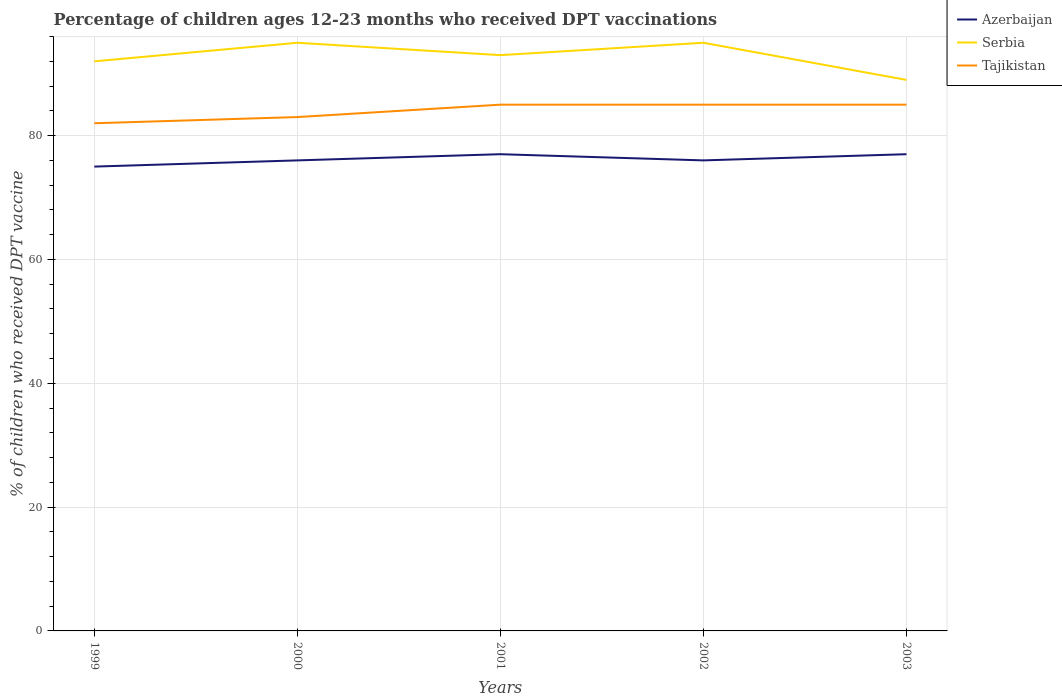How many different coloured lines are there?
Your answer should be very brief. 3. In which year was the percentage of children who received DPT vaccination in Serbia maximum?
Offer a very short reply. 2003. Is the percentage of children who received DPT vaccination in Azerbaijan strictly greater than the percentage of children who received DPT vaccination in Tajikistan over the years?
Your response must be concise. Yes. How many lines are there?
Make the answer very short. 3. How many years are there in the graph?
Make the answer very short. 5. What is the difference between two consecutive major ticks on the Y-axis?
Provide a short and direct response. 20. Are the values on the major ticks of Y-axis written in scientific E-notation?
Give a very brief answer. No. Does the graph contain any zero values?
Your response must be concise. No. What is the title of the graph?
Your response must be concise. Percentage of children ages 12-23 months who received DPT vaccinations. Does "Brunei Darussalam" appear as one of the legend labels in the graph?
Provide a succinct answer. No. What is the label or title of the X-axis?
Offer a very short reply. Years. What is the label or title of the Y-axis?
Offer a terse response. % of children who received DPT vaccine. What is the % of children who received DPT vaccine of Serbia in 1999?
Your answer should be very brief. 92. What is the % of children who received DPT vaccine in Tajikistan in 1999?
Offer a terse response. 82. What is the % of children who received DPT vaccine in Serbia in 2000?
Provide a succinct answer. 95. What is the % of children who received DPT vaccine in Serbia in 2001?
Your answer should be compact. 93. What is the % of children who received DPT vaccine in Tajikistan in 2001?
Give a very brief answer. 85. What is the % of children who received DPT vaccine in Azerbaijan in 2002?
Ensure brevity in your answer.  76. What is the % of children who received DPT vaccine in Azerbaijan in 2003?
Offer a very short reply. 77. What is the % of children who received DPT vaccine in Serbia in 2003?
Keep it short and to the point. 89. Across all years, what is the maximum % of children who received DPT vaccine in Azerbaijan?
Provide a succinct answer. 77. Across all years, what is the maximum % of children who received DPT vaccine of Serbia?
Your response must be concise. 95. Across all years, what is the maximum % of children who received DPT vaccine of Tajikistan?
Ensure brevity in your answer.  85. Across all years, what is the minimum % of children who received DPT vaccine of Serbia?
Ensure brevity in your answer.  89. Across all years, what is the minimum % of children who received DPT vaccine of Tajikistan?
Provide a short and direct response. 82. What is the total % of children who received DPT vaccine of Azerbaijan in the graph?
Your answer should be very brief. 381. What is the total % of children who received DPT vaccine of Serbia in the graph?
Provide a succinct answer. 464. What is the total % of children who received DPT vaccine in Tajikistan in the graph?
Offer a very short reply. 420. What is the difference between the % of children who received DPT vaccine of Azerbaijan in 1999 and that in 2000?
Provide a succinct answer. -1. What is the difference between the % of children who received DPT vaccine in Azerbaijan in 1999 and that in 2001?
Give a very brief answer. -2. What is the difference between the % of children who received DPT vaccine in Serbia in 1999 and that in 2002?
Ensure brevity in your answer.  -3. What is the difference between the % of children who received DPT vaccine in Azerbaijan in 2000 and that in 2001?
Ensure brevity in your answer.  -1. What is the difference between the % of children who received DPT vaccine of Serbia in 2000 and that in 2001?
Your response must be concise. 2. What is the difference between the % of children who received DPT vaccine in Azerbaijan in 2000 and that in 2002?
Provide a succinct answer. 0. What is the difference between the % of children who received DPT vaccine in Serbia in 2000 and that in 2002?
Your answer should be very brief. 0. What is the difference between the % of children who received DPT vaccine of Tajikistan in 2000 and that in 2002?
Provide a short and direct response. -2. What is the difference between the % of children who received DPT vaccine of Serbia in 2000 and that in 2003?
Give a very brief answer. 6. What is the difference between the % of children who received DPT vaccine in Azerbaijan in 2001 and that in 2002?
Offer a terse response. 1. What is the difference between the % of children who received DPT vaccine of Serbia in 2002 and that in 2003?
Ensure brevity in your answer.  6. What is the difference between the % of children who received DPT vaccine in Tajikistan in 2002 and that in 2003?
Provide a succinct answer. 0. What is the difference between the % of children who received DPT vaccine in Azerbaijan in 1999 and the % of children who received DPT vaccine in Serbia in 2000?
Your answer should be compact. -20. What is the difference between the % of children who received DPT vaccine of Azerbaijan in 1999 and the % of children who received DPT vaccine of Tajikistan in 2000?
Provide a succinct answer. -8. What is the difference between the % of children who received DPT vaccine in Serbia in 1999 and the % of children who received DPT vaccine in Tajikistan in 2000?
Offer a terse response. 9. What is the difference between the % of children who received DPT vaccine in Azerbaijan in 1999 and the % of children who received DPT vaccine in Tajikistan in 2001?
Your response must be concise. -10. What is the difference between the % of children who received DPT vaccine in Serbia in 1999 and the % of children who received DPT vaccine in Tajikistan in 2001?
Offer a terse response. 7. What is the difference between the % of children who received DPT vaccine in Azerbaijan in 1999 and the % of children who received DPT vaccine in Serbia in 2002?
Ensure brevity in your answer.  -20. What is the difference between the % of children who received DPT vaccine of Serbia in 1999 and the % of children who received DPT vaccine of Tajikistan in 2002?
Keep it short and to the point. 7. What is the difference between the % of children who received DPT vaccine in Azerbaijan in 2000 and the % of children who received DPT vaccine in Tajikistan in 2001?
Your answer should be very brief. -9. What is the difference between the % of children who received DPT vaccine in Serbia in 2000 and the % of children who received DPT vaccine in Tajikistan in 2001?
Make the answer very short. 10. What is the difference between the % of children who received DPT vaccine in Azerbaijan in 2000 and the % of children who received DPT vaccine in Serbia in 2002?
Give a very brief answer. -19. What is the difference between the % of children who received DPT vaccine of Azerbaijan in 2000 and the % of children who received DPT vaccine of Tajikistan in 2002?
Ensure brevity in your answer.  -9. What is the difference between the % of children who received DPT vaccine in Serbia in 2000 and the % of children who received DPT vaccine in Tajikistan in 2002?
Your answer should be very brief. 10. What is the difference between the % of children who received DPT vaccine in Azerbaijan in 2000 and the % of children who received DPT vaccine in Tajikistan in 2003?
Offer a very short reply. -9. What is the difference between the % of children who received DPT vaccine in Serbia in 2000 and the % of children who received DPT vaccine in Tajikistan in 2003?
Your answer should be compact. 10. What is the difference between the % of children who received DPT vaccine in Azerbaijan in 2001 and the % of children who received DPT vaccine in Serbia in 2002?
Your answer should be compact. -18. What is the difference between the % of children who received DPT vaccine of Azerbaijan in 2001 and the % of children who received DPT vaccine of Tajikistan in 2002?
Your response must be concise. -8. What is the difference between the % of children who received DPT vaccine in Serbia in 2001 and the % of children who received DPT vaccine in Tajikistan in 2003?
Provide a short and direct response. 8. What is the difference between the % of children who received DPT vaccine in Azerbaijan in 2002 and the % of children who received DPT vaccine in Serbia in 2003?
Offer a terse response. -13. What is the difference between the % of children who received DPT vaccine of Serbia in 2002 and the % of children who received DPT vaccine of Tajikistan in 2003?
Offer a very short reply. 10. What is the average % of children who received DPT vaccine in Azerbaijan per year?
Ensure brevity in your answer.  76.2. What is the average % of children who received DPT vaccine in Serbia per year?
Provide a succinct answer. 92.8. What is the average % of children who received DPT vaccine of Tajikistan per year?
Your answer should be compact. 84. In the year 1999, what is the difference between the % of children who received DPT vaccine of Azerbaijan and % of children who received DPT vaccine of Tajikistan?
Offer a terse response. -7. In the year 2000, what is the difference between the % of children who received DPT vaccine of Azerbaijan and % of children who received DPT vaccine of Serbia?
Offer a terse response. -19. In the year 2000, what is the difference between the % of children who received DPT vaccine in Azerbaijan and % of children who received DPT vaccine in Tajikistan?
Make the answer very short. -7. In the year 2000, what is the difference between the % of children who received DPT vaccine of Serbia and % of children who received DPT vaccine of Tajikistan?
Keep it short and to the point. 12. In the year 2001, what is the difference between the % of children who received DPT vaccine in Azerbaijan and % of children who received DPT vaccine in Serbia?
Offer a terse response. -16. In the year 2001, what is the difference between the % of children who received DPT vaccine in Serbia and % of children who received DPT vaccine in Tajikistan?
Keep it short and to the point. 8. In the year 2002, what is the difference between the % of children who received DPT vaccine in Azerbaijan and % of children who received DPT vaccine in Serbia?
Keep it short and to the point. -19. In the year 2002, what is the difference between the % of children who received DPT vaccine of Azerbaijan and % of children who received DPT vaccine of Tajikistan?
Provide a succinct answer. -9. In the year 2002, what is the difference between the % of children who received DPT vaccine in Serbia and % of children who received DPT vaccine in Tajikistan?
Your answer should be very brief. 10. In the year 2003, what is the difference between the % of children who received DPT vaccine in Serbia and % of children who received DPT vaccine in Tajikistan?
Your response must be concise. 4. What is the ratio of the % of children who received DPT vaccine of Azerbaijan in 1999 to that in 2000?
Your answer should be very brief. 0.99. What is the ratio of the % of children who received DPT vaccine in Serbia in 1999 to that in 2000?
Make the answer very short. 0.97. What is the ratio of the % of children who received DPT vaccine in Serbia in 1999 to that in 2001?
Your answer should be compact. 0.99. What is the ratio of the % of children who received DPT vaccine of Tajikistan in 1999 to that in 2001?
Your answer should be very brief. 0.96. What is the ratio of the % of children who received DPT vaccine in Serbia in 1999 to that in 2002?
Your answer should be very brief. 0.97. What is the ratio of the % of children who received DPT vaccine in Tajikistan in 1999 to that in 2002?
Provide a succinct answer. 0.96. What is the ratio of the % of children who received DPT vaccine of Serbia in 1999 to that in 2003?
Make the answer very short. 1.03. What is the ratio of the % of children who received DPT vaccine of Tajikistan in 1999 to that in 2003?
Give a very brief answer. 0.96. What is the ratio of the % of children who received DPT vaccine in Serbia in 2000 to that in 2001?
Provide a short and direct response. 1.02. What is the ratio of the % of children who received DPT vaccine in Tajikistan in 2000 to that in 2001?
Give a very brief answer. 0.98. What is the ratio of the % of children who received DPT vaccine in Tajikistan in 2000 to that in 2002?
Provide a short and direct response. 0.98. What is the ratio of the % of children who received DPT vaccine in Azerbaijan in 2000 to that in 2003?
Provide a short and direct response. 0.99. What is the ratio of the % of children who received DPT vaccine of Serbia in 2000 to that in 2003?
Offer a terse response. 1.07. What is the ratio of the % of children who received DPT vaccine of Tajikistan in 2000 to that in 2003?
Make the answer very short. 0.98. What is the ratio of the % of children who received DPT vaccine in Azerbaijan in 2001 to that in 2002?
Offer a very short reply. 1.01. What is the ratio of the % of children who received DPT vaccine of Serbia in 2001 to that in 2002?
Offer a very short reply. 0.98. What is the ratio of the % of children who received DPT vaccine of Azerbaijan in 2001 to that in 2003?
Give a very brief answer. 1. What is the ratio of the % of children who received DPT vaccine of Serbia in 2001 to that in 2003?
Your answer should be compact. 1.04. What is the ratio of the % of children who received DPT vaccine of Tajikistan in 2001 to that in 2003?
Keep it short and to the point. 1. What is the ratio of the % of children who received DPT vaccine in Serbia in 2002 to that in 2003?
Keep it short and to the point. 1.07. What is the ratio of the % of children who received DPT vaccine in Tajikistan in 2002 to that in 2003?
Make the answer very short. 1. What is the difference between the highest and the second highest % of children who received DPT vaccine in Serbia?
Make the answer very short. 0. What is the difference between the highest and the second highest % of children who received DPT vaccine in Tajikistan?
Your answer should be compact. 0. 